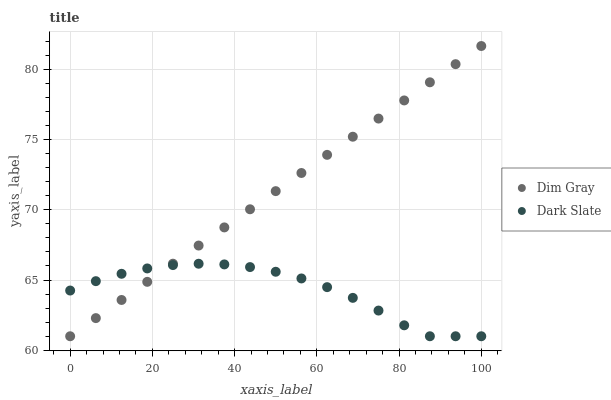Does Dark Slate have the minimum area under the curve?
Answer yes or no. Yes. Does Dim Gray have the maximum area under the curve?
Answer yes or no. Yes. Does Dim Gray have the minimum area under the curve?
Answer yes or no. No. Is Dim Gray the smoothest?
Answer yes or no. Yes. Is Dark Slate the roughest?
Answer yes or no. Yes. Is Dim Gray the roughest?
Answer yes or no. No. Does Dark Slate have the lowest value?
Answer yes or no. Yes. Does Dim Gray have the highest value?
Answer yes or no. Yes. Does Dark Slate intersect Dim Gray?
Answer yes or no. Yes. Is Dark Slate less than Dim Gray?
Answer yes or no. No. Is Dark Slate greater than Dim Gray?
Answer yes or no. No. 